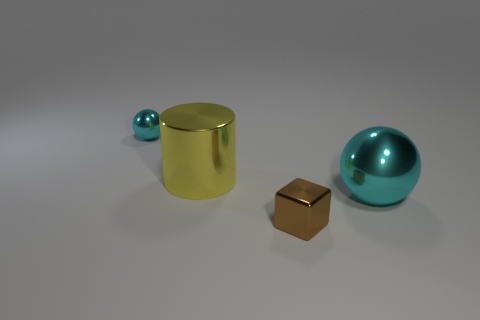Which object in the image casts the strongest shadow? The cylindrical object casts the strongest shadow, suggesting it has a larger mass or is closer to the light source in comparison to the other objects. 